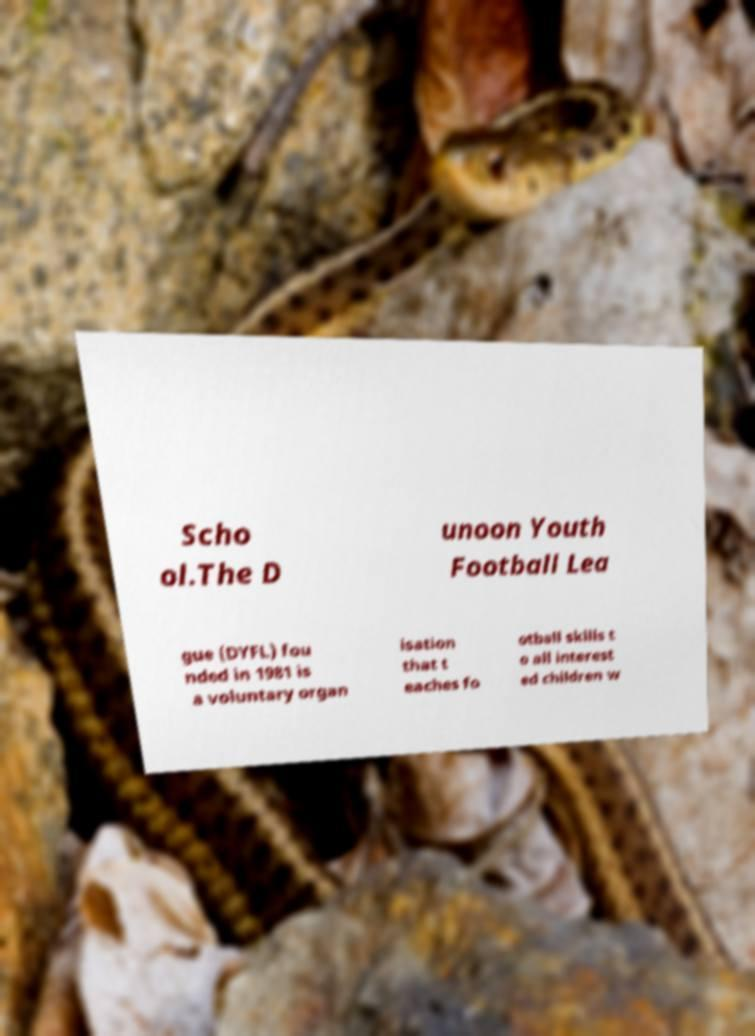Can you read and provide the text displayed in the image?This photo seems to have some interesting text. Can you extract and type it out for me? Scho ol.The D unoon Youth Football Lea gue (DYFL) fou nded in 1981 is a voluntary organ isation that t eaches fo otball skills t o all interest ed children w 